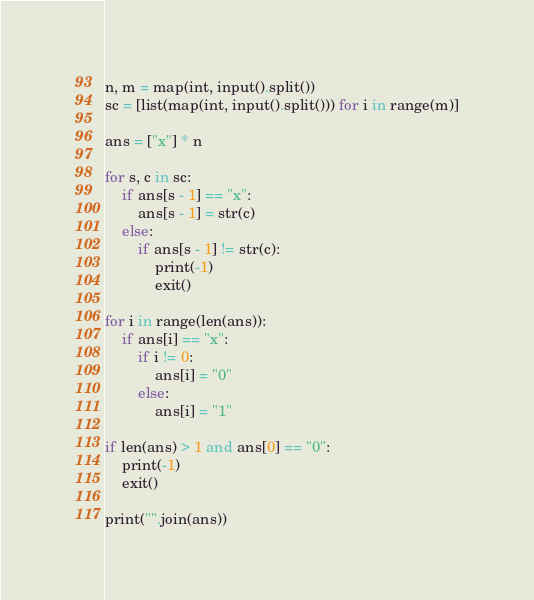<code> <loc_0><loc_0><loc_500><loc_500><_Python_>n, m = map(int, input().split())
sc = [list(map(int, input().split())) for i in range(m)]

ans = ["x"] * n

for s, c in sc:
    if ans[s - 1] == "x":
        ans[s - 1] = str(c)
    else:
        if ans[s - 1] != str(c):
            print(-1)
            exit()

for i in range(len(ans)):
    if ans[i] == "x":
        if i != 0:
            ans[i] = "0"
        else:
            ans[i] = "1"

if len(ans) > 1 and ans[0] == "0":
    print(-1)
    exit()

print("".join(ans))</code> 